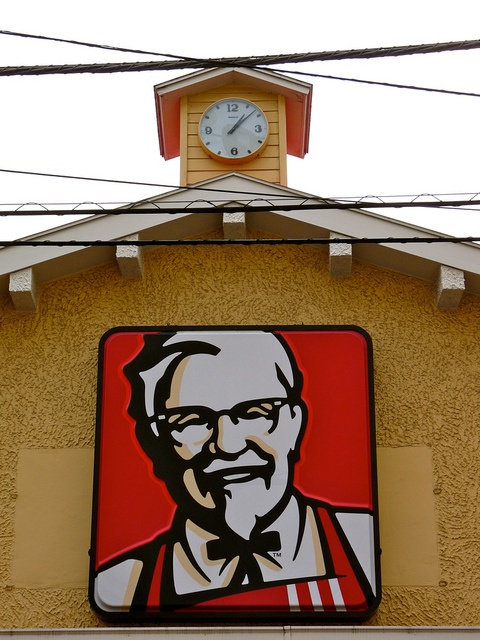Describe the objects in this image and their specific colors. I can see clock in white, darkgray, gray, olive, and maroon tones and tie in white, black, darkgray, gray, and tan tones in this image. 